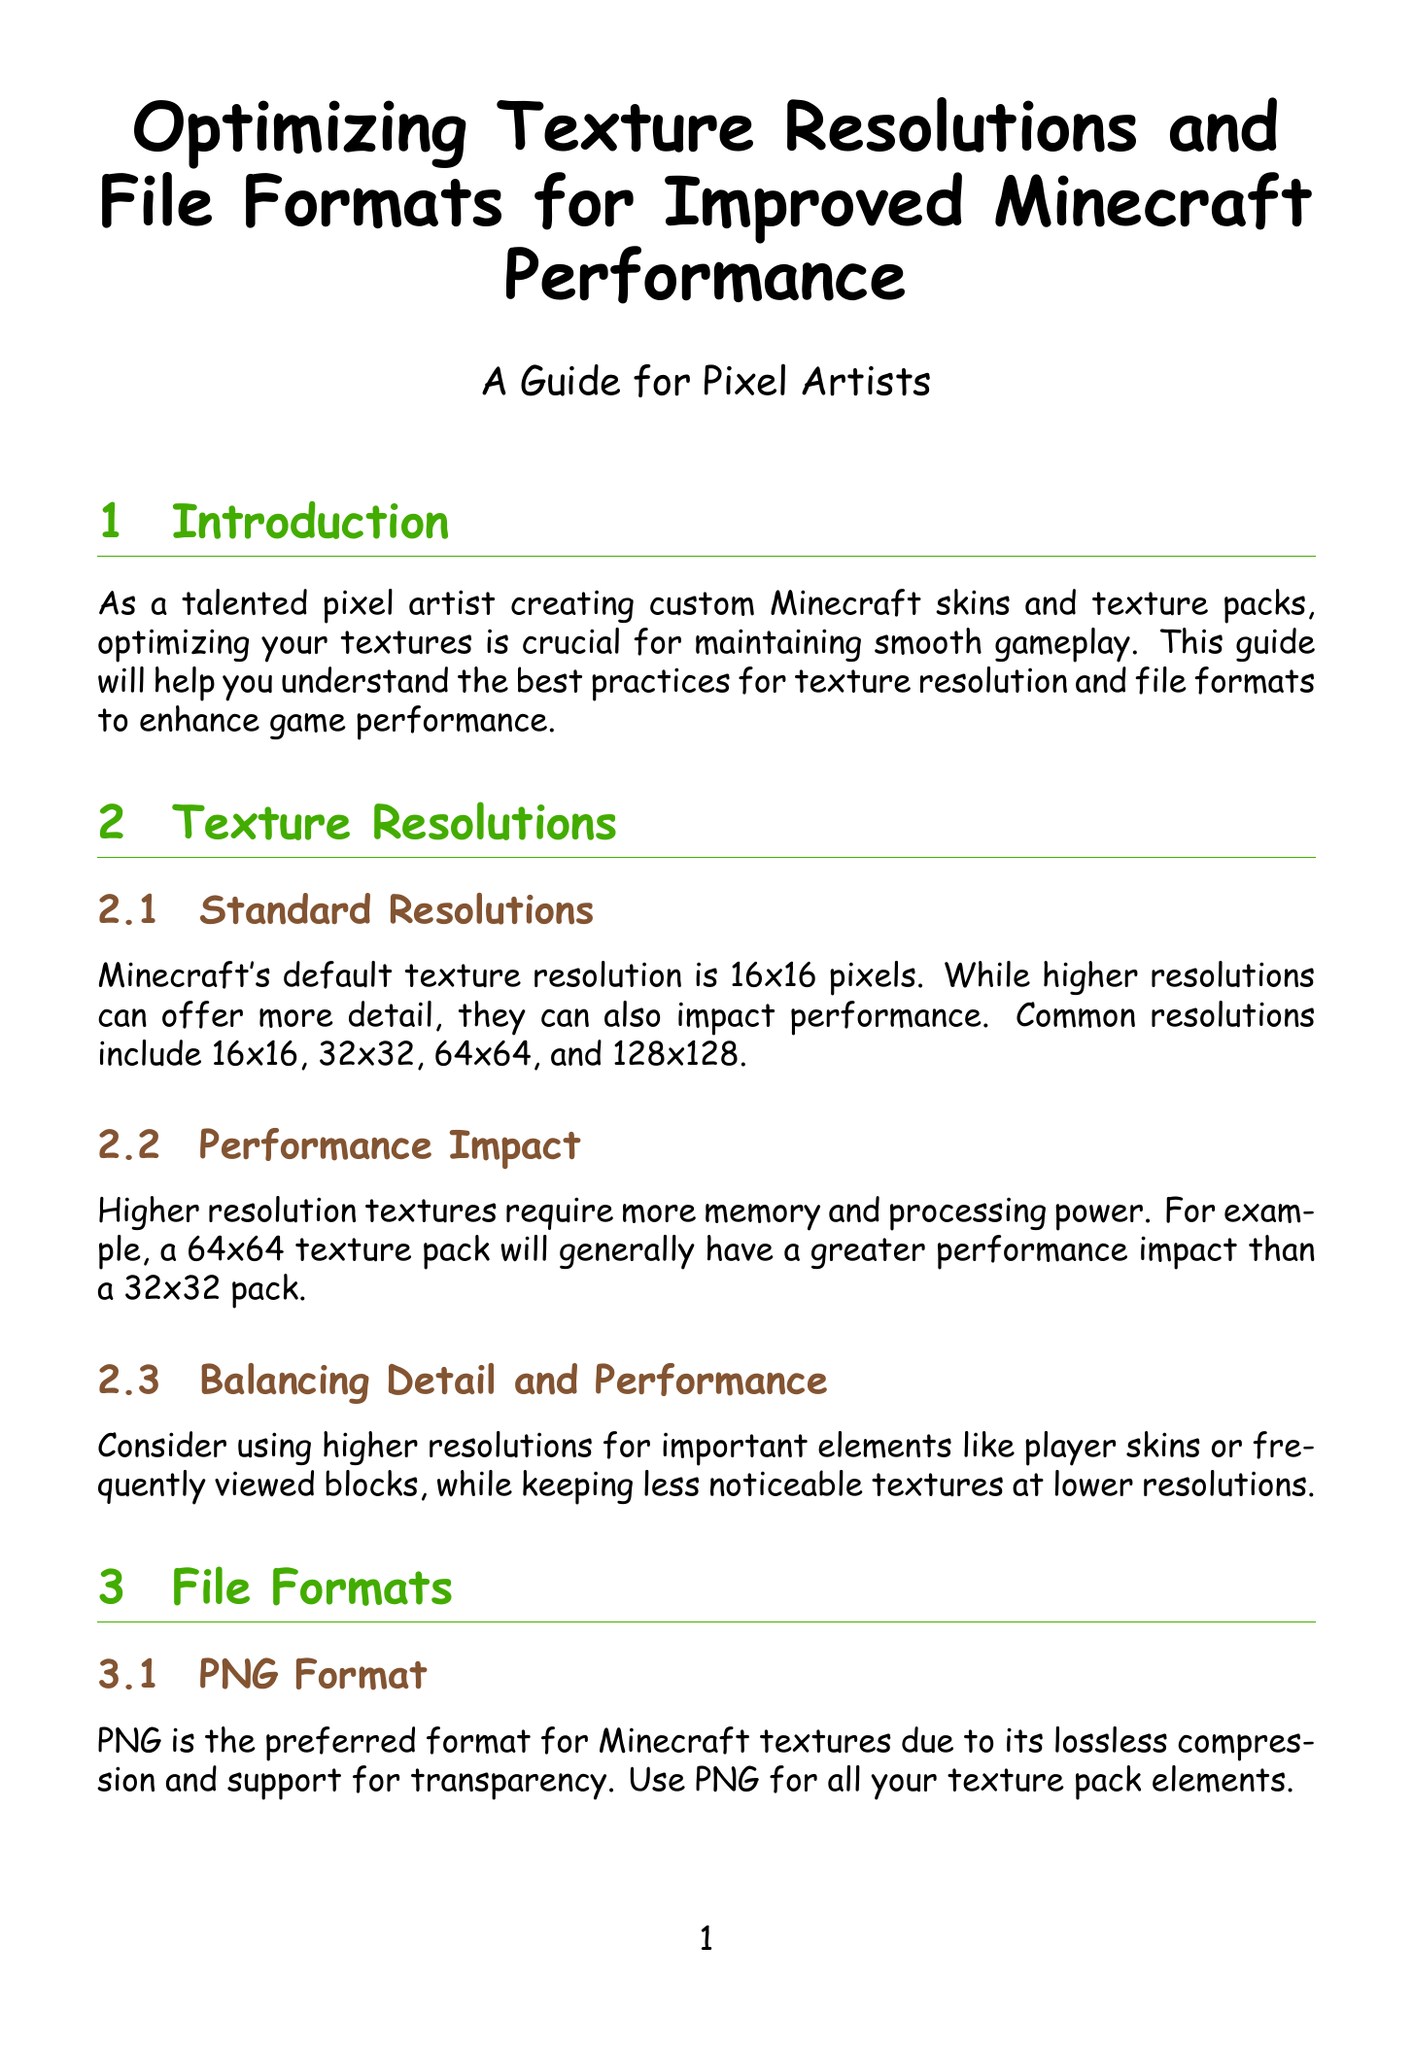What is the default texture resolution in Minecraft? The default texture resolution mentioned in the document is 16x16 pixels.
Answer: 16x16 What is the preferred file format for Minecraft textures? The document states that PNG is the preferred format for Minecraft textures.
Answer: PNG What resolution has a greater performance impact than 32x32? The document indicates that a 64x64 texture pack has a greater performance impact than a 32x32 pack.
Answer: 64x64 Which technique can be used to reduce file sizes without losing quality? The document mentions using tools like PNGGauntlet or TinyPNG for compression without losing quality.
Answer: PNGGauntlet Why should JPEG files be avoided for Minecraft textures? The document states that JPEG files do not support transparency and can introduce artifacts.
Answer: Transparency, artifacts What should be focused on optimizing due to performance impact? The document advises focusing on frequently used blocks like dirt, stone, and wood for optimization.
Answer: Dirt, stone, wood What feature can improve rendering at different distances? The document suggests creating mipmaps for textures to improve rendering.
Answer: Mipmaps How can multiple textures be combined for better performance? The document explains that combining multiple textures into a single atlas can improve performance.
Answer: Texture atlases 